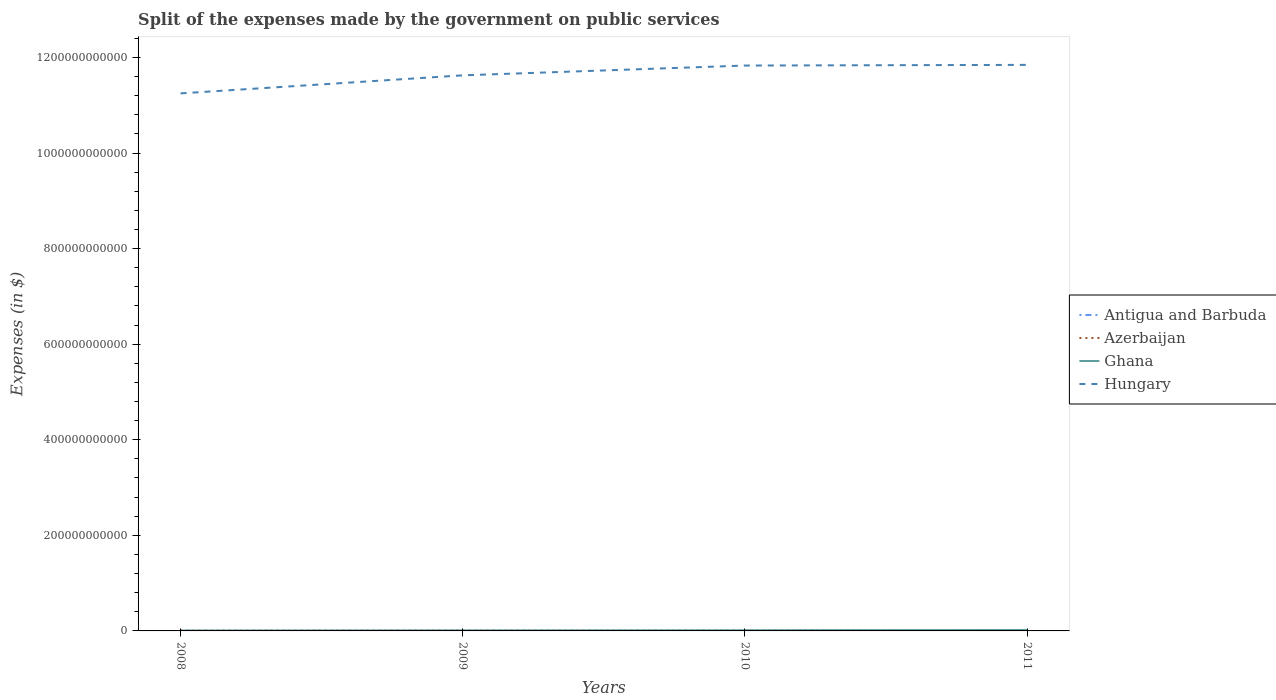Across all years, what is the maximum expenses made by the government on public services in Azerbaijan?
Keep it short and to the point. 6.80e+08. What is the total expenses made by the government on public services in Antigua and Barbuda in the graph?
Provide a short and direct response. 4.53e+07. What is the difference between the highest and the second highest expenses made by the government on public services in Antigua and Barbuda?
Your answer should be very brief. 5.95e+07. Is the expenses made by the government on public services in Azerbaijan strictly greater than the expenses made by the government on public services in Hungary over the years?
Your response must be concise. Yes. How many lines are there?
Provide a succinct answer. 4. What is the difference between two consecutive major ticks on the Y-axis?
Your response must be concise. 2.00e+11. Does the graph contain grids?
Your answer should be very brief. No. How are the legend labels stacked?
Provide a short and direct response. Vertical. What is the title of the graph?
Provide a succinct answer. Split of the expenses made by the government on public services. Does "Caribbean small states" appear as one of the legend labels in the graph?
Provide a short and direct response. No. What is the label or title of the X-axis?
Provide a short and direct response. Years. What is the label or title of the Y-axis?
Provide a succinct answer. Expenses (in $). What is the Expenses (in $) of Antigua and Barbuda in 2008?
Provide a short and direct response. 1.85e+08. What is the Expenses (in $) of Azerbaijan in 2008?
Give a very brief answer. 6.80e+08. What is the Expenses (in $) of Ghana in 2008?
Offer a very short reply. 7.44e+08. What is the Expenses (in $) of Hungary in 2008?
Offer a terse response. 1.12e+12. What is the Expenses (in $) in Antigua and Barbuda in 2009?
Make the answer very short. 1.71e+08. What is the Expenses (in $) of Azerbaijan in 2009?
Your answer should be compact. 7.90e+08. What is the Expenses (in $) in Ghana in 2009?
Offer a terse response. 1.09e+09. What is the Expenses (in $) in Hungary in 2009?
Your answer should be very brief. 1.16e+12. What is the Expenses (in $) in Antigua and Barbuda in 2010?
Give a very brief answer. 1.26e+08. What is the Expenses (in $) of Azerbaijan in 2010?
Your answer should be compact. 8.63e+08. What is the Expenses (in $) in Ghana in 2010?
Make the answer very short. 1.37e+09. What is the Expenses (in $) of Hungary in 2010?
Keep it short and to the point. 1.18e+12. What is the Expenses (in $) in Antigua and Barbuda in 2011?
Your answer should be very brief. 1.26e+08. What is the Expenses (in $) in Azerbaijan in 2011?
Your answer should be very brief. 9.36e+08. What is the Expenses (in $) in Ghana in 2011?
Provide a short and direct response. 2.00e+09. What is the Expenses (in $) in Hungary in 2011?
Your answer should be compact. 1.18e+12. Across all years, what is the maximum Expenses (in $) in Antigua and Barbuda?
Make the answer very short. 1.85e+08. Across all years, what is the maximum Expenses (in $) in Azerbaijan?
Your response must be concise. 9.36e+08. Across all years, what is the maximum Expenses (in $) in Ghana?
Provide a short and direct response. 2.00e+09. Across all years, what is the maximum Expenses (in $) of Hungary?
Your response must be concise. 1.18e+12. Across all years, what is the minimum Expenses (in $) of Antigua and Barbuda?
Keep it short and to the point. 1.26e+08. Across all years, what is the minimum Expenses (in $) in Azerbaijan?
Offer a very short reply. 6.80e+08. Across all years, what is the minimum Expenses (in $) of Ghana?
Keep it short and to the point. 7.44e+08. Across all years, what is the minimum Expenses (in $) in Hungary?
Provide a short and direct response. 1.12e+12. What is the total Expenses (in $) in Antigua and Barbuda in the graph?
Keep it short and to the point. 6.07e+08. What is the total Expenses (in $) of Azerbaijan in the graph?
Your answer should be compact. 3.27e+09. What is the total Expenses (in $) in Ghana in the graph?
Your answer should be very brief. 5.20e+09. What is the total Expenses (in $) in Hungary in the graph?
Provide a succinct answer. 4.65e+12. What is the difference between the Expenses (in $) in Antigua and Barbuda in 2008 and that in 2009?
Give a very brief answer. 1.40e+07. What is the difference between the Expenses (in $) in Azerbaijan in 2008 and that in 2009?
Your answer should be compact. -1.09e+08. What is the difference between the Expenses (in $) of Ghana in 2008 and that in 2009?
Your answer should be compact. -3.44e+08. What is the difference between the Expenses (in $) in Hungary in 2008 and that in 2009?
Provide a succinct answer. -3.77e+1. What is the difference between the Expenses (in $) of Antigua and Barbuda in 2008 and that in 2010?
Your answer should be very brief. 5.95e+07. What is the difference between the Expenses (in $) of Azerbaijan in 2008 and that in 2010?
Make the answer very short. -1.83e+08. What is the difference between the Expenses (in $) of Ghana in 2008 and that in 2010?
Give a very brief answer. -6.28e+08. What is the difference between the Expenses (in $) of Hungary in 2008 and that in 2010?
Offer a terse response. -5.83e+1. What is the difference between the Expenses (in $) in Antigua and Barbuda in 2008 and that in 2011?
Give a very brief answer. 5.93e+07. What is the difference between the Expenses (in $) of Azerbaijan in 2008 and that in 2011?
Your answer should be compact. -2.56e+08. What is the difference between the Expenses (in $) of Ghana in 2008 and that in 2011?
Give a very brief answer. -1.26e+09. What is the difference between the Expenses (in $) in Hungary in 2008 and that in 2011?
Your answer should be compact. -5.97e+1. What is the difference between the Expenses (in $) in Antigua and Barbuda in 2009 and that in 2010?
Your answer should be very brief. 4.55e+07. What is the difference between the Expenses (in $) of Azerbaijan in 2009 and that in 2010?
Offer a terse response. -7.34e+07. What is the difference between the Expenses (in $) of Ghana in 2009 and that in 2010?
Give a very brief answer. -2.84e+08. What is the difference between the Expenses (in $) in Hungary in 2009 and that in 2010?
Provide a short and direct response. -2.05e+1. What is the difference between the Expenses (in $) in Antigua and Barbuda in 2009 and that in 2011?
Offer a terse response. 4.53e+07. What is the difference between the Expenses (in $) in Azerbaijan in 2009 and that in 2011?
Your answer should be compact. -1.46e+08. What is the difference between the Expenses (in $) of Ghana in 2009 and that in 2011?
Your answer should be compact. -9.14e+08. What is the difference between the Expenses (in $) in Hungary in 2009 and that in 2011?
Ensure brevity in your answer.  -2.19e+1. What is the difference between the Expenses (in $) in Antigua and Barbuda in 2010 and that in 2011?
Your response must be concise. -2.00e+05. What is the difference between the Expenses (in $) of Azerbaijan in 2010 and that in 2011?
Give a very brief answer. -7.29e+07. What is the difference between the Expenses (in $) of Ghana in 2010 and that in 2011?
Provide a succinct answer. -6.30e+08. What is the difference between the Expenses (in $) in Hungary in 2010 and that in 2011?
Provide a succinct answer. -1.40e+09. What is the difference between the Expenses (in $) in Antigua and Barbuda in 2008 and the Expenses (in $) in Azerbaijan in 2009?
Provide a succinct answer. -6.05e+08. What is the difference between the Expenses (in $) in Antigua and Barbuda in 2008 and the Expenses (in $) in Ghana in 2009?
Your answer should be very brief. -9.02e+08. What is the difference between the Expenses (in $) in Antigua and Barbuda in 2008 and the Expenses (in $) in Hungary in 2009?
Make the answer very short. -1.16e+12. What is the difference between the Expenses (in $) in Azerbaijan in 2008 and the Expenses (in $) in Ghana in 2009?
Your response must be concise. -4.07e+08. What is the difference between the Expenses (in $) in Azerbaijan in 2008 and the Expenses (in $) in Hungary in 2009?
Offer a terse response. -1.16e+12. What is the difference between the Expenses (in $) of Ghana in 2008 and the Expenses (in $) of Hungary in 2009?
Your answer should be very brief. -1.16e+12. What is the difference between the Expenses (in $) of Antigua and Barbuda in 2008 and the Expenses (in $) of Azerbaijan in 2010?
Provide a succinct answer. -6.78e+08. What is the difference between the Expenses (in $) in Antigua and Barbuda in 2008 and the Expenses (in $) in Ghana in 2010?
Ensure brevity in your answer.  -1.19e+09. What is the difference between the Expenses (in $) in Antigua and Barbuda in 2008 and the Expenses (in $) in Hungary in 2010?
Your answer should be very brief. -1.18e+12. What is the difference between the Expenses (in $) in Azerbaijan in 2008 and the Expenses (in $) in Ghana in 2010?
Provide a succinct answer. -6.91e+08. What is the difference between the Expenses (in $) in Azerbaijan in 2008 and the Expenses (in $) in Hungary in 2010?
Your answer should be compact. -1.18e+12. What is the difference between the Expenses (in $) of Ghana in 2008 and the Expenses (in $) of Hungary in 2010?
Give a very brief answer. -1.18e+12. What is the difference between the Expenses (in $) in Antigua and Barbuda in 2008 and the Expenses (in $) in Azerbaijan in 2011?
Make the answer very short. -7.51e+08. What is the difference between the Expenses (in $) of Antigua and Barbuda in 2008 and the Expenses (in $) of Ghana in 2011?
Make the answer very short. -1.82e+09. What is the difference between the Expenses (in $) in Antigua and Barbuda in 2008 and the Expenses (in $) in Hungary in 2011?
Offer a terse response. -1.18e+12. What is the difference between the Expenses (in $) of Azerbaijan in 2008 and the Expenses (in $) of Ghana in 2011?
Offer a terse response. -1.32e+09. What is the difference between the Expenses (in $) in Azerbaijan in 2008 and the Expenses (in $) in Hungary in 2011?
Ensure brevity in your answer.  -1.18e+12. What is the difference between the Expenses (in $) of Ghana in 2008 and the Expenses (in $) of Hungary in 2011?
Provide a succinct answer. -1.18e+12. What is the difference between the Expenses (in $) in Antigua and Barbuda in 2009 and the Expenses (in $) in Azerbaijan in 2010?
Make the answer very short. -6.92e+08. What is the difference between the Expenses (in $) of Antigua and Barbuda in 2009 and the Expenses (in $) of Ghana in 2010?
Provide a short and direct response. -1.20e+09. What is the difference between the Expenses (in $) of Antigua and Barbuda in 2009 and the Expenses (in $) of Hungary in 2010?
Keep it short and to the point. -1.18e+12. What is the difference between the Expenses (in $) in Azerbaijan in 2009 and the Expenses (in $) in Ghana in 2010?
Provide a succinct answer. -5.82e+08. What is the difference between the Expenses (in $) in Azerbaijan in 2009 and the Expenses (in $) in Hungary in 2010?
Provide a short and direct response. -1.18e+12. What is the difference between the Expenses (in $) in Ghana in 2009 and the Expenses (in $) in Hungary in 2010?
Ensure brevity in your answer.  -1.18e+12. What is the difference between the Expenses (in $) of Antigua and Barbuda in 2009 and the Expenses (in $) of Azerbaijan in 2011?
Your answer should be very brief. -7.65e+08. What is the difference between the Expenses (in $) in Antigua and Barbuda in 2009 and the Expenses (in $) in Ghana in 2011?
Ensure brevity in your answer.  -1.83e+09. What is the difference between the Expenses (in $) in Antigua and Barbuda in 2009 and the Expenses (in $) in Hungary in 2011?
Your response must be concise. -1.18e+12. What is the difference between the Expenses (in $) in Azerbaijan in 2009 and the Expenses (in $) in Ghana in 2011?
Provide a short and direct response. -1.21e+09. What is the difference between the Expenses (in $) in Azerbaijan in 2009 and the Expenses (in $) in Hungary in 2011?
Offer a very short reply. -1.18e+12. What is the difference between the Expenses (in $) in Ghana in 2009 and the Expenses (in $) in Hungary in 2011?
Offer a terse response. -1.18e+12. What is the difference between the Expenses (in $) of Antigua and Barbuda in 2010 and the Expenses (in $) of Azerbaijan in 2011?
Give a very brief answer. -8.11e+08. What is the difference between the Expenses (in $) of Antigua and Barbuda in 2010 and the Expenses (in $) of Ghana in 2011?
Provide a succinct answer. -1.88e+09. What is the difference between the Expenses (in $) of Antigua and Barbuda in 2010 and the Expenses (in $) of Hungary in 2011?
Provide a short and direct response. -1.18e+12. What is the difference between the Expenses (in $) of Azerbaijan in 2010 and the Expenses (in $) of Ghana in 2011?
Keep it short and to the point. -1.14e+09. What is the difference between the Expenses (in $) of Azerbaijan in 2010 and the Expenses (in $) of Hungary in 2011?
Your answer should be compact. -1.18e+12. What is the difference between the Expenses (in $) of Ghana in 2010 and the Expenses (in $) of Hungary in 2011?
Keep it short and to the point. -1.18e+12. What is the average Expenses (in $) of Antigua and Barbuda per year?
Offer a very short reply. 1.52e+08. What is the average Expenses (in $) in Azerbaijan per year?
Your response must be concise. 8.17e+08. What is the average Expenses (in $) of Ghana per year?
Make the answer very short. 1.30e+09. What is the average Expenses (in $) in Hungary per year?
Your answer should be very brief. 1.16e+12. In the year 2008, what is the difference between the Expenses (in $) of Antigua and Barbuda and Expenses (in $) of Azerbaijan?
Ensure brevity in your answer.  -4.96e+08. In the year 2008, what is the difference between the Expenses (in $) of Antigua and Barbuda and Expenses (in $) of Ghana?
Your answer should be compact. -5.59e+08. In the year 2008, what is the difference between the Expenses (in $) in Antigua and Barbuda and Expenses (in $) in Hungary?
Ensure brevity in your answer.  -1.12e+12. In the year 2008, what is the difference between the Expenses (in $) of Azerbaijan and Expenses (in $) of Ghana?
Your answer should be very brief. -6.33e+07. In the year 2008, what is the difference between the Expenses (in $) of Azerbaijan and Expenses (in $) of Hungary?
Offer a terse response. -1.12e+12. In the year 2008, what is the difference between the Expenses (in $) in Ghana and Expenses (in $) in Hungary?
Provide a short and direct response. -1.12e+12. In the year 2009, what is the difference between the Expenses (in $) in Antigua and Barbuda and Expenses (in $) in Azerbaijan?
Your response must be concise. -6.19e+08. In the year 2009, what is the difference between the Expenses (in $) in Antigua and Barbuda and Expenses (in $) in Ghana?
Your response must be concise. -9.16e+08. In the year 2009, what is the difference between the Expenses (in $) of Antigua and Barbuda and Expenses (in $) of Hungary?
Make the answer very short. -1.16e+12. In the year 2009, what is the difference between the Expenses (in $) in Azerbaijan and Expenses (in $) in Ghana?
Offer a terse response. -2.98e+08. In the year 2009, what is the difference between the Expenses (in $) in Azerbaijan and Expenses (in $) in Hungary?
Your response must be concise. -1.16e+12. In the year 2009, what is the difference between the Expenses (in $) in Ghana and Expenses (in $) in Hungary?
Provide a succinct answer. -1.16e+12. In the year 2010, what is the difference between the Expenses (in $) of Antigua and Barbuda and Expenses (in $) of Azerbaijan?
Ensure brevity in your answer.  -7.38e+08. In the year 2010, what is the difference between the Expenses (in $) in Antigua and Barbuda and Expenses (in $) in Ghana?
Keep it short and to the point. -1.25e+09. In the year 2010, what is the difference between the Expenses (in $) in Antigua and Barbuda and Expenses (in $) in Hungary?
Keep it short and to the point. -1.18e+12. In the year 2010, what is the difference between the Expenses (in $) of Azerbaijan and Expenses (in $) of Ghana?
Give a very brief answer. -5.08e+08. In the year 2010, what is the difference between the Expenses (in $) in Azerbaijan and Expenses (in $) in Hungary?
Your response must be concise. -1.18e+12. In the year 2010, what is the difference between the Expenses (in $) of Ghana and Expenses (in $) of Hungary?
Provide a succinct answer. -1.18e+12. In the year 2011, what is the difference between the Expenses (in $) in Antigua and Barbuda and Expenses (in $) in Azerbaijan?
Your answer should be compact. -8.10e+08. In the year 2011, what is the difference between the Expenses (in $) of Antigua and Barbuda and Expenses (in $) of Ghana?
Offer a terse response. -1.88e+09. In the year 2011, what is the difference between the Expenses (in $) in Antigua and Barbuda and Expenses (in $) in Hungary?
Ensure brevity in your answer.  -1.18e+12. In the year 2011, what is the difference between the Expenses (in $) of Azerbaijan and Expenses (in $) of Ghana?
Give a very brief answer. -1.07e+09. In the year 2011, what is the difference between the Expenses (in $) of Azerbaijan and Expenses (in $) of Hungary?
Ensure brevity in your answer.  -1.18e+12. In the year 2011, what is the difference between the Expenses (in $) of Ghana and Expenses (in $) of Hungary?
Your response must be concise. -1.18e+12. What is the ratio of the Expenses (in $) in Antigua and Barbuda in 2008 to that in 2009?
Your answer should be very brief. 1.08. What is the ratio of the Expenses (in $) in Azerbaijan in 2008 to that in 2009?
Your response must be concise. 0.86. What is the ratio of the Expenses (in $) in Ghana in 2008 to that in 2009?
Your answer should be compact. 0.68. What is the ratio of the Expenses (in $) in Hungary in 2008 to that in 2009?
Give a very brief answer. 0.97. What is the ratio of the Expenses (in $) of Antigua and Barbuda in 2008 to that in 2010?
Provide a succinct answer. 1.47. What is the ratio of the Expenses (in $) of Azerbaijan in 2008 to that in 2010?
Your answer should be compact. 0.79. What is the ratio of the Expenses (in $) of Ghana in 2008 to that in 2010?
Provide a succinct answer. 0.54. What is the ratio of the Expenses (in $) in Hungary in 2008 to that in 2010?
Provide a succinct answer. 0.95. What is the ratio of the Expenses (in $) in Antigua and Barbuda in 2008 to that in 2011?
Offer a very short reply. 1.47. What is the ratio of the Expenses (in $) in Azerbaijan in 2008 to that in 2011?
Provide a succinct answer. 0.73. What is the ratio of the Expenses (in $) in Ghana in 2008 to that in 2011?
Provide a short and direct response. 0.37. What is the ratio of the Expenses (in $) of Hungary in 2008 to that in 2011?
Provide a succinct answer. 0.95. What is the ratio of the Expenses (in $) of Antigua and Barbuda in 2009 to that in 2010?
Provide a succinct answer. 1.36. What is the ratio of the Expenses (in $) of Azerbaijan in 2009 to that in 2010?
Your answer should be compact. 0.92. What is the ratio of the Expenses (in $) of Ghana in 2009 to that in 2010?
Keep it short and to the point. 0.79. What is the ratio of the Expenses (in $) of Hungary in 2009 to that in 2010?
Provide a short and direct response. 0.98. What is the ratio of the Expenses (in $) in Antigua and Barbuda in 2009 to that in 2011?
Provide a succinct answer. 1.36. What is the ratio of the Expenses (in $) of Azerbaijan in 2009 to that in 2011?
Offer a very short reply. 0.84. What is the ratio of the Expenses (in $) in Ghana in 2009 to that in 2011?
Your answer should be very brief. 0.54. What is the ratio of the Expenses (in $) of Hungary in 2009 to that in 2011?
Your response must be concise. 0.98. What is the ratio of the Expenses (in $) in Azerbaijan in 2010 to that in 2011?
Provide a succinct answer. 0.92. What is the ratio of the Expenses (in $) in Ghana in 2010 to that in 2011?
Offer a very short reply. 0.69. What is the difference between the highest and the second highest Expenses (in $) in Antigua and Barbuda?
Ensure brevity in your answer.  1.40e+07. What is the difference between the highest and the second highest Expenses (in $) of Azerbaijan?
Keep it short and to the point. 7.29e+07. What is the difference between the highest and the second highest Expenses (in $) of Ghana?
Keep it short and to the point. 6.30e+08. What is the difference between the highest and the second highest Expenses (in $) in Hungary?
Ensure brevity in your answer.  1.40e+09. What is the difference between the highest and the lowest Expenses (in $) of Antigua and Barbuda?
Make the answer very short. 5.95e+07. What is the difference between the highest and the lowest Expenses (in $) of Azerbaijan?
Your response must be concise. 2.56e+08. What is the difference between the highest and the lowest Expenses (in $) in Ghana?
Ensure brevity in your answer.  1.26e+09. What is the difference between the highest and the lowest Expenses (in $) of Hungary?
Your answer should be compact. 5.97e+1. 